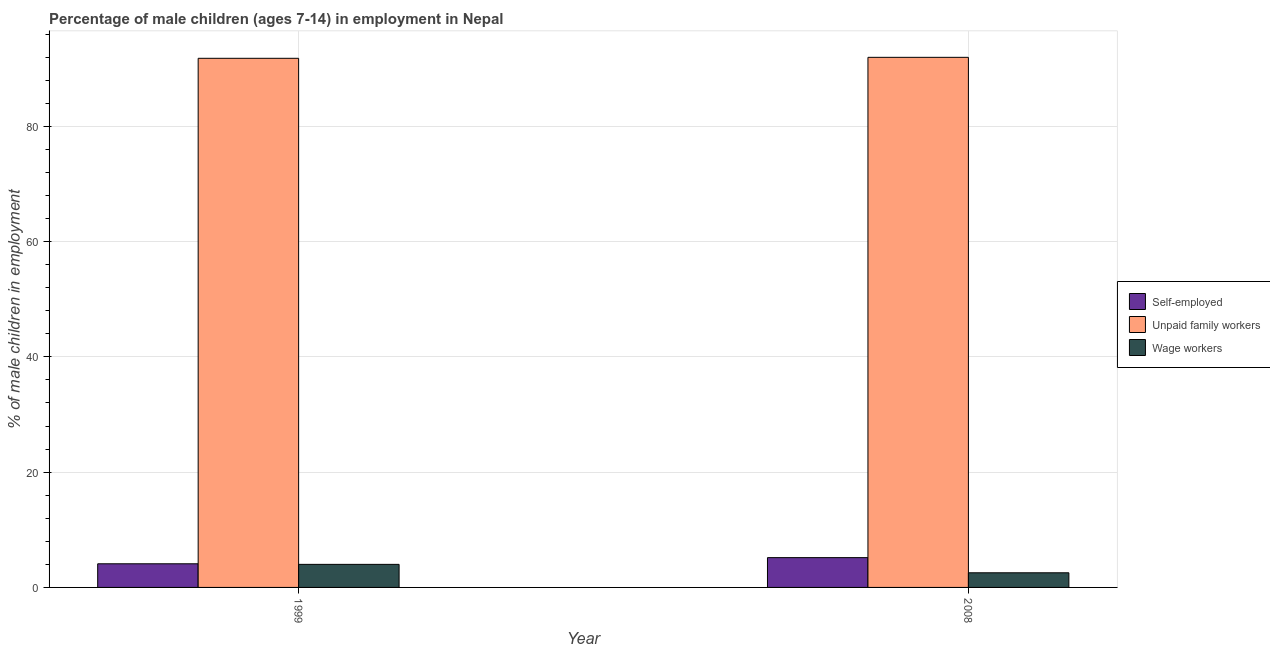How many groups of bars are there?
Offer a terse response. 2. Are the number of bars per tick equal to the number of legend labels?
Provide a succinct answer. Yes. How many bars are there on the 2nd tick from the right?
Offer a very short reply. 3. What is the label of the 1st group of bars from the left?
Your answer should be very brief. 1999. In how many cases, is the number of bars for a given year not equal to the number of legend labels?
Your answer should be very brief. 0. What is the percentage of children employed as wage workers in 2008?
Give a very brief answer. 2.54. Across all years, what is the maximum percentage of children employed as unpaid family workers?
Offer a very short reply. 91.97. What is the total percentage of children employed as unpaid family workers in the graph?
Give a very brief answer. 183.77. What is the difference between the percentage of children employed as unpaid family workers in 1999 and that in 2008?
Make the answer very short. -0.17. What is the difference between the percentage of children employed as unpaid family workers in 1999 and the percentage of children employed as wage workers in 2008?
Your answer should be compact. -0.17. What is the average percentage of children employed as wage workers per year?
Give a very brief answer. 3.27. What is the ratio of the percentage of children employed as wage workers in 1999 to that in 2008?
Ensure brevity in your answer.  1.57. Is the percentage of children employed as unpaid family workers in 1999 less than that in 2008?
Keep it short and to the point. Yes. In how many years, is the percentage of self employed children greater than the average percentage of self employed children taken over all years?
Provide a succinct answer. 1. What does the 2nd bar from the left in 2008 represents?
Your answer should be very brief. Unpaid family workers. What does the 1st bar from the right in 2008 represents?
Provide a succinct answer. Wage workers. Are all the bars in the graph horizontal?
Make the answer very short. No. Are the values on the major ticks of Y-axis written in scientific E-notation?
Your response must be concise. No. How many legend labels are there?
Offer a terse response. 3. What is the title of the graph?
Your response must be concise. Percentage of male children (ages 7-14) in employment in Nepal. What is the label or title of the Y-axis?
Keep it short and to the point. % of male children in employment. What is the % of male children in employment in Self-employed in 1999?
Offer a terse response. 4.1. What is the % of male children in employment of Unpaid family workers in 1999?
Provide a succinct answer. 91.8. What is the % of male children in employment of Wage workers in 1999?
Offer a very short reply. 4. What is the % of male children in employment in Self-employed in 2008?
Provide a succinct answer. 5.17. What is the % of male children in employment of Unpaid family workers in 2008?
Ensure brevity in your answer.  91.97. What is the % of male children in employment of Wage workers in 2008?
Give a very brief answer. 2.54. Across all years, what is the maximum % of male children in employment in Self-employed?
Give a very brief answer. 5.17. Across all years, what is the maximum % of male children in employment of Unpaid family workers?
Offer a very short reply. 91.97. Across all years, what is the maximum % of male children in employment in Wage workers?
Your response must be concise. 4. Across all years, what is the minimum % of male children in employment in Unpaid family workers?
Your response must be concise. 91.8. Across all years, what is the minimum % of male children in employment of Wage workers?
Offer a terse response. 2.54. What is the total % of male children in employment in Self-employed in the graph?
Ensure brevity in your answer.  9.27. What is the total % of male children in employment in Unpaid family workers in the graph?
Ensure brevity in your answer.  183.77. What is the total % of male children in employment in Wage workers in the graph?
Give a very brief answer. 6.54. What is the difference between the % of male children in employment of Self-employed in 1999 and that in 2008?
Give a very brief answer. -1.07. What is the difference between the % of male children in employment in Unpaid family workers in 1999 and that in 2008?
Make the answer very short. -0.17. What is the difference between the % of male children in employment in Wage workers in 1999 and that in 2008?
Keep it short and to the point. 1.46. What is the difference between the % of male children in employment of Self-employed in 1999 and the % of male children in employment of Unpaid family workers in 2008?
Provide a succinct answer. -87.87. What is the difference between the % of male children in employment of Self-employed in 1999 and the % of male children in employment of Wage workers in 2008?
Make the answer very short. 1.56. What is the difference between the % of male children in employment of Unpaid family workers in 1999 and the % of male children in employment of Wage workers in 2008?
Make the answer very short. 89.26. What is the average % of male children in employment of Self-employed per year?
Ensure brevity in your answer.  4.63. What is the average % of male children in employment in Unpaid family workers per year?
Provide a succinct answer. 91.89. What is the average % of male children in employment of Wage workers per year?
Ensure brevity in your answer.  3.27. In the year 1999, what is the difference between the % of male children in employment of Self-employed and % of male children in employment of Unpaid family workers?
Your answer should be compact. -87.7. In the year 1999, what is the difference between the % of male children in employment of Self-employed and % of male children in employment of Wage workers?
Provide a short and direct response. 0.1. In the year 1999, what is the difference between the % of male children in employment of Unpaid family workers and % of male children in employment of Wage workers?
Your response must be concise. 87.8. In the year 2008, what is the difference between the % of male children in employment in Self-employed and % of male children in employment in Unpaid family workers?
Give a very brief answer. -86.8. In the year 2008, what is the difference between the % of male children in employment of Self-employed and % of male children in employment of Wage workers?
Your answer should be compact. 2.63. In the year 2008, what is the difference between the % of male children in employment of Unpaid family workers and % of male children in employment of Wage workers?
Keep it short and to the point. 89.43. What is the ratio of the % of male children in employment in Self-employed in 1999 to that in 2008?
Your response must be concise. 0.79. What is the ratio of the % of male children in employment in Unpaid family workers in 1999 to that in 2008?
Provide a succinct answer. 1. What is the ratio of the % of male children in employment in Wage workers in 1999 to that in 2008?
Your answer should be very brief. 1.57. What is the difference between the highest and the second highest % of male children in employment in Self-employed?
Ensure brevity in your answer.  1.07. What is the difference between the highest and the second highest % of male children in employment of Unpaid family workers?
Make the answer very short. 0.17. What is the difference between the highest and the second highest % of male children in employment of Wage workers?
Provide a succinct answer. 1.46. What is the difference between the highest and the lowest % of male children in employment of Self-employed?
Ensure brevity in your answer.  1.07. What is the difference between the highest and the lowest % of male children in employment in Unpaid family workers?
Give a very brief answer. 0.17. What is the difference between the highest and the lowest % of male children in employment of Wage workers?
Your answer should be compact. 1.46. 